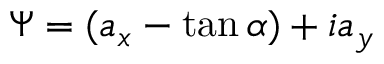<formula> <loc_0><loc_0><loc_500><loc_500>\Psi = ( a _ { x } - \tan \alpha ) + i a _ { y }</formula> 